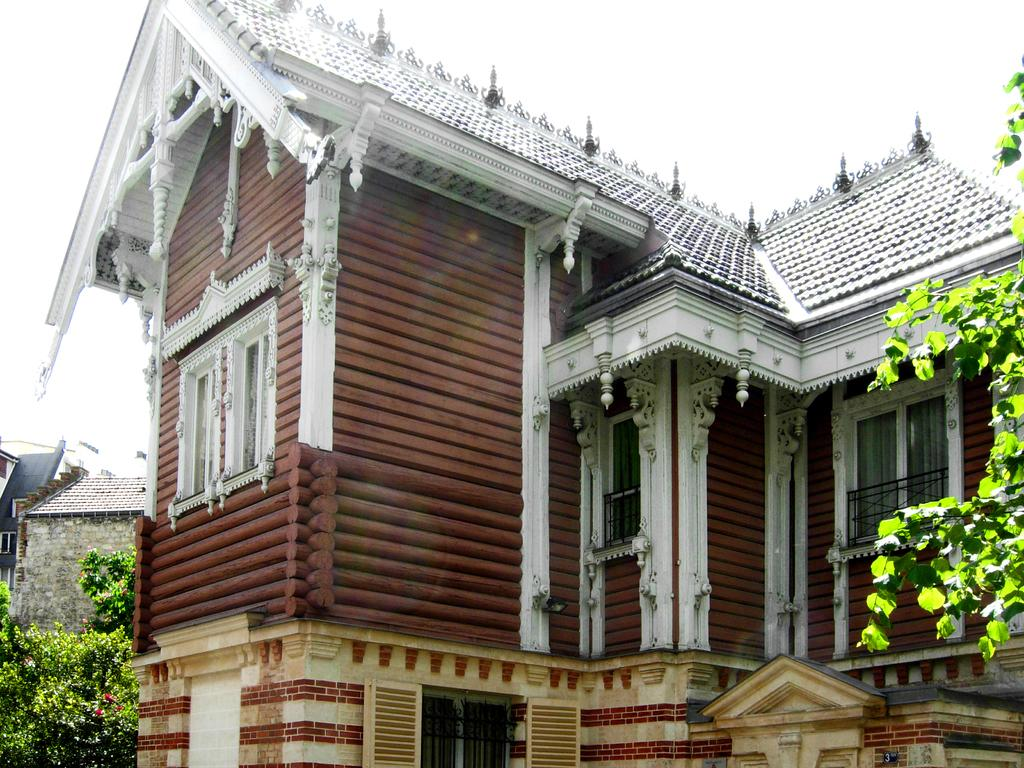What type of structures can be seen in the image? There are houses in the image. What other natural elements are present in the image? There are trees in the image. What part of the environment is visible in the image? The sky is visible in the image. What type of vegetation can be seen on the right side of the image? There are leaves on the right side of the image. What type of food is being kicked in the image? There is no food or kicking activity present in the image. 